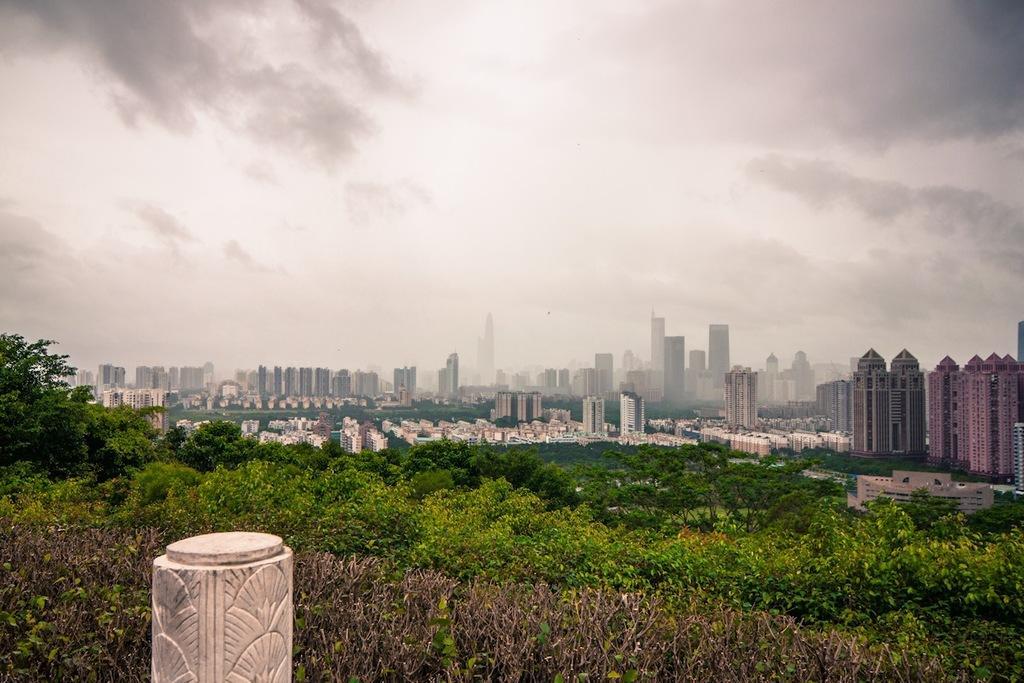Describe this image in one or two sentences. This is an outside view. At the bottom there are many plants and trees. In the background there are many buildings. At the top of the image I can see the sky and clouds. In the bottom left-hand corner there is a pillar. 